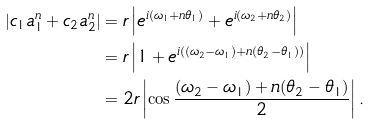<formula> <loc_0><loc_0><loc_500><loc_500>\left | c _ { 1 } a _ { 1 } ^ { n } + c _ { 2 } a _ { 2 } ^ { n } \right | & = r \left | e ^ { i ( \omega _ { 1 } + n \theta _ { 1 } ) } + e ^ { i ( \omega _ { 2 } + n \theta _ { 2 } ) } \right | \\ & = r \left | 1 + e ^ { i ( ( \omega _ { 2 } - \omega _ { 1 } ) + n ( \theta _ { 2 } - \theta _ { 1 } ) ) } \right | \\ & = 2 r \left | \cos \frac { ( \omega _ { 2 } - \omega _ { 1 } ) + n ( \theta _ { 2 } - \theta _ { 1 } ) } { 2 } \right | .</formula> 